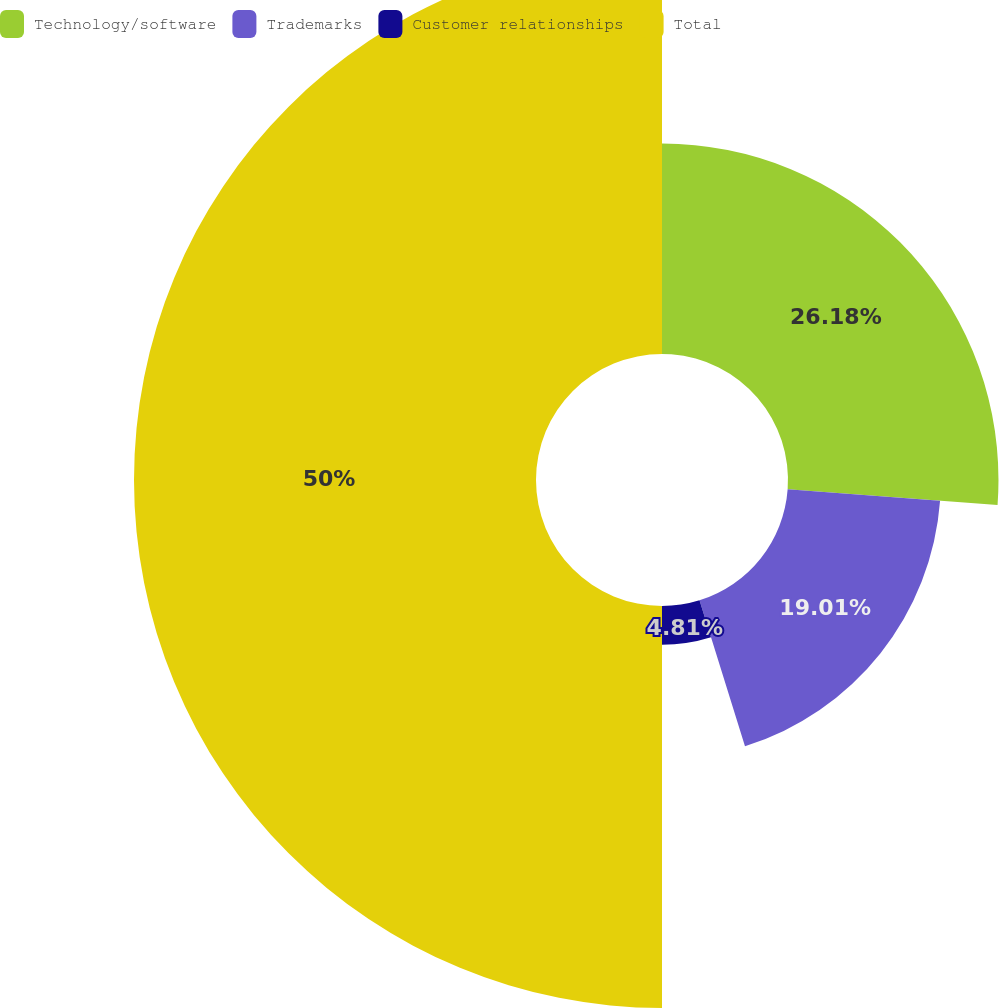Convert chart to OTSL. <chart><loc_0><loc_0><loc_500><loc_500><pie_chart><fcel>Technology/software<fcel>Trademarks<fcel>Customer relationships<fcel>Total<nl><fcel>26.18%<fcel>19.01%<fcel>4.81%<fcel>50.0%<nl></chart> 